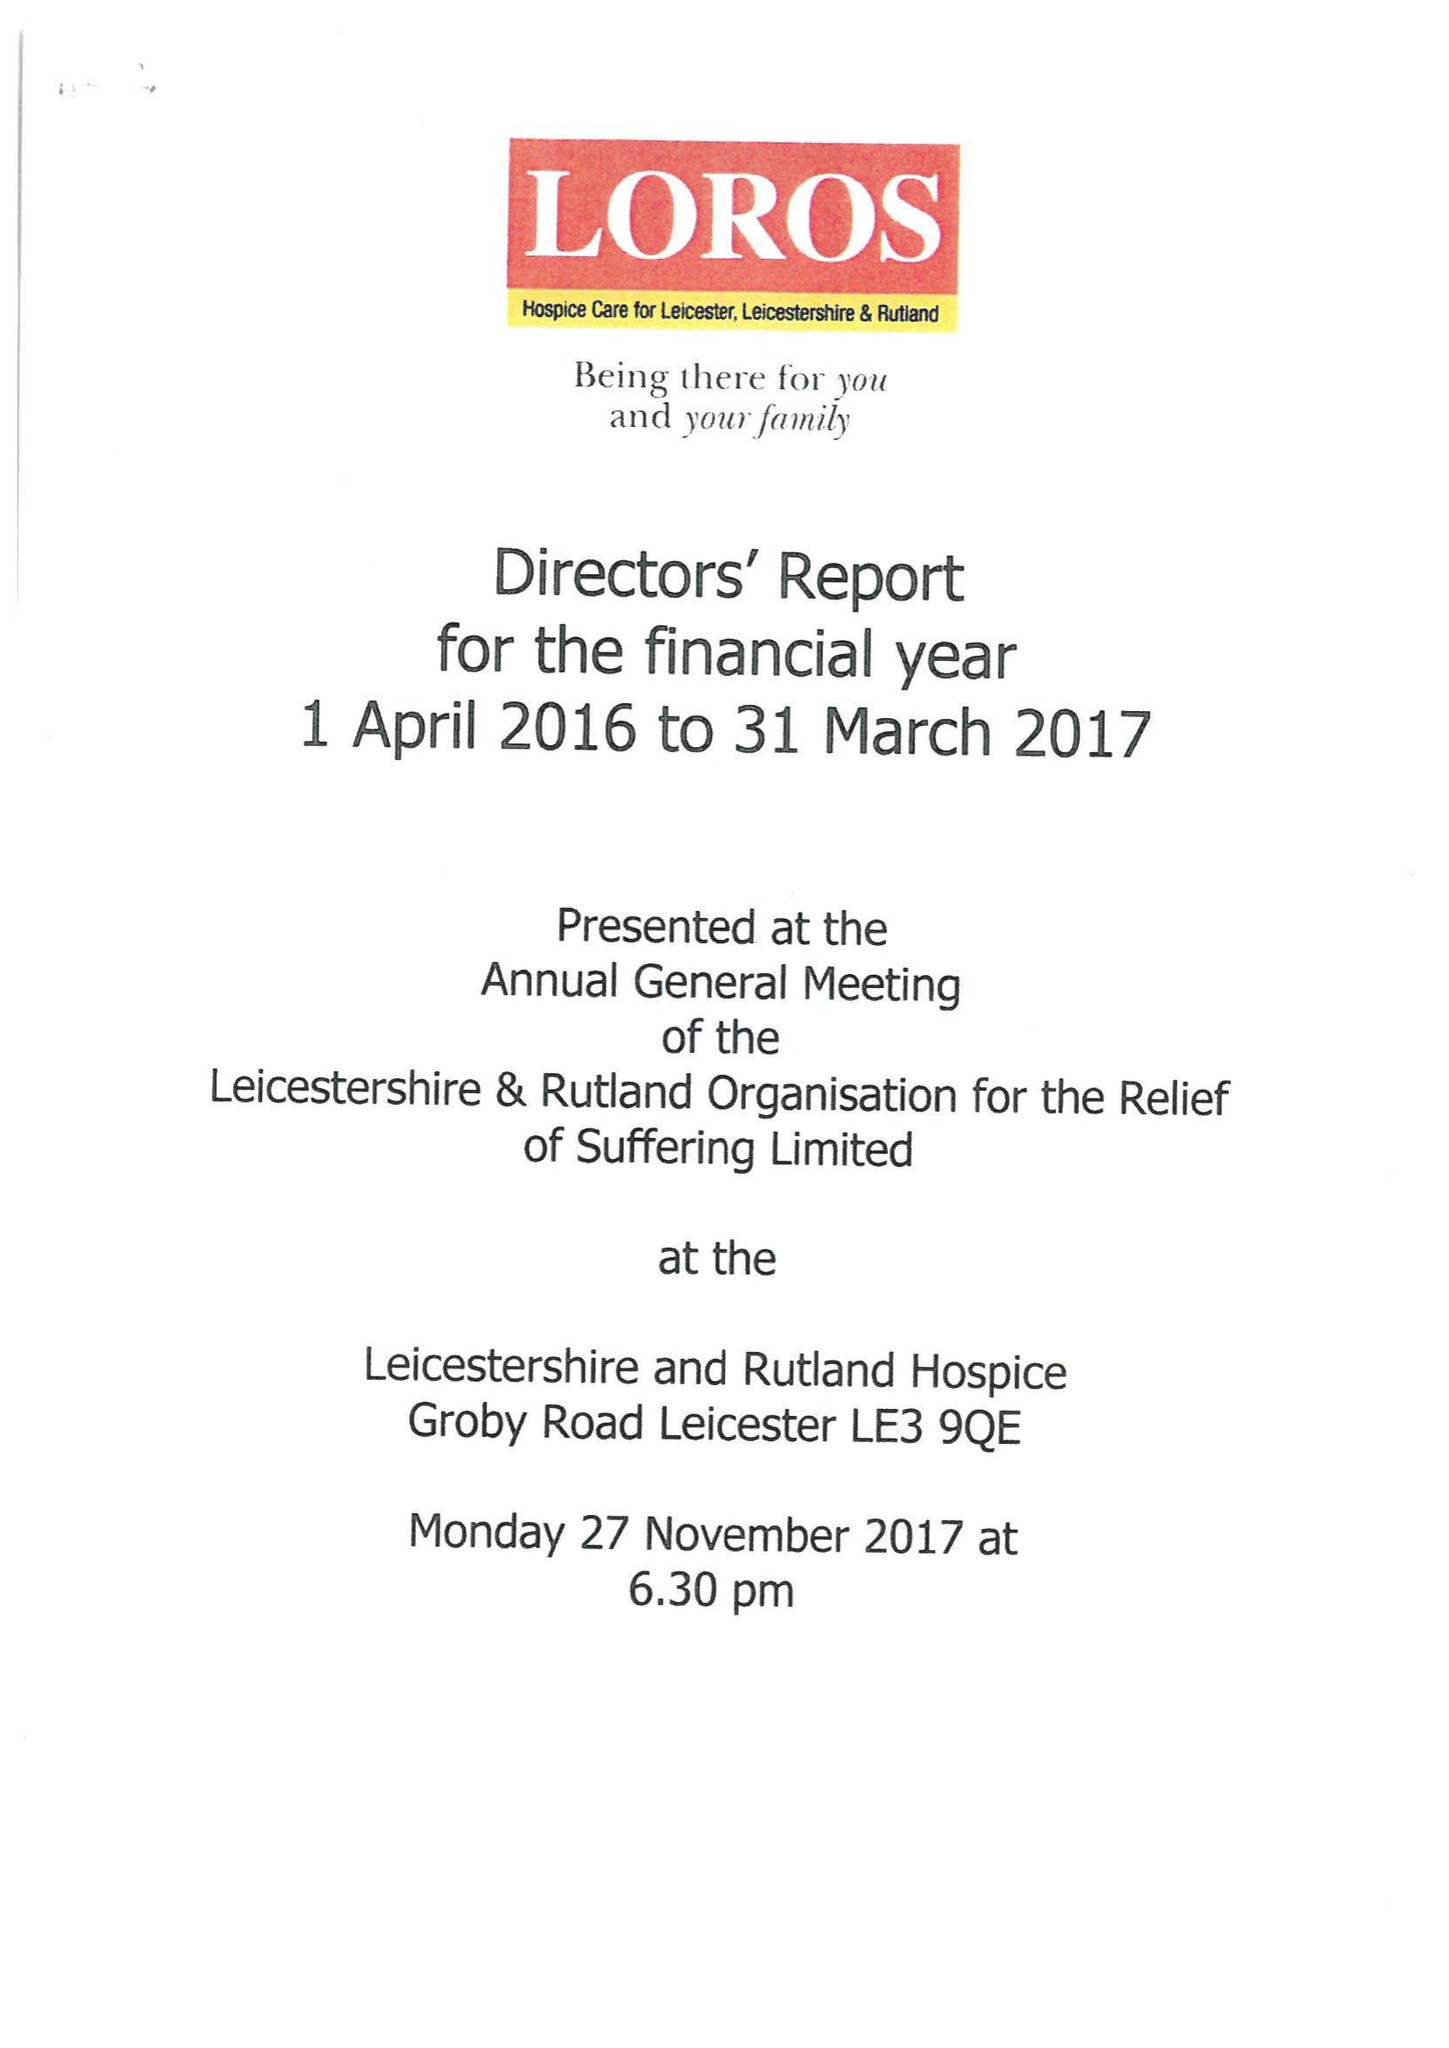What is the value for the charity_name?
Answer the question using a single word or phrase. Leicestershire and Rutland Organisation For The Relief Of Suffering Ltd. 